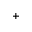Convert formula to latex. <formula><loc_0><loc_0><loc_500><loc_500>+</formula> 